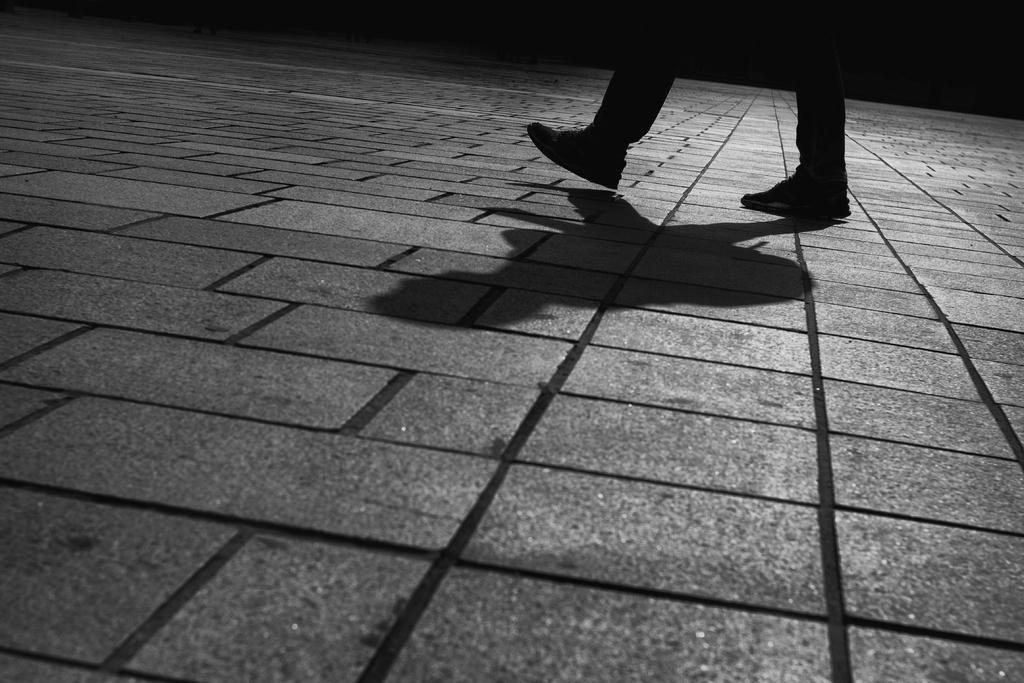What part of a person can be seen in the image? There are legs of a person in the image. What is the surface that the person is standing on? The ground is visible in the image. Is there any indication of the person's presence besides their legs? Yes, there is a shadow in the image. What type of letters can be seen in the store in the image? There is no store or letters present in the image; it only features legs and a shadow. 